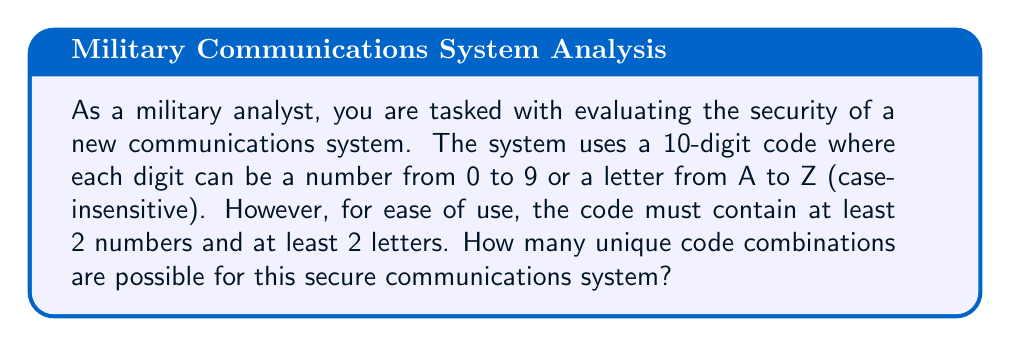Can you solve this math problem? Let's approach this step-by-step:

1) First, we need to calculate the total number of options for each digit:
   - 10 numbers (0-9)
   - 26 letters (A-Z)
   Total options per digit: $10 + 26 = 36$

2) Now, we need to use the inclusion-exclusion principle to solve this problem:

   Let A be the set of all 10-digit codes with at least 2 numbers
   Let B be the set of all 10-digit codes with at least 2 letters

   We want to find $|A \cap B|$

3) Total number of 10-digit codes: $36^{10}$

4) Number of codes with fewer than 2 numbers:
   $26^{10} + \binom{10}{1}10 \cdot 26^9$

5) Number of codes with fewer than 2 letters:
   $10^{10} + \binom{10}{1}26 \cdot 10^9$

6) Using the inclusion-exclusion principle:

   $$|A \cap B| = 36^{10} - (26^{10} + \binom{10}{1}10 \cdot 26^9) - (10^{10} + \binom{10}{1}26 \cdot 10^9) + (26^{10} + 10^{10})$$

7) Simplify:
   $$|A \cap B| = 36^{10} - \binom{10}{1}10 \cdot 26^9 - \binom{10}{1}26 \cdot 10^9$$

8) Calculate:
   $$|A \cap B| = 3656158440062976 - 2600 \cdot 5070942774758400 - 260 \cdot 10000000000$$

   $$|A \cap B| = 3656158440062976 - 13184451214371840 - 2600000000000$$

   $$|A \cap B| = 3642973988848605136$$
Answer: There are 3,642,973,988,848,605,136 unique code combinations possible for this secure communications system. 